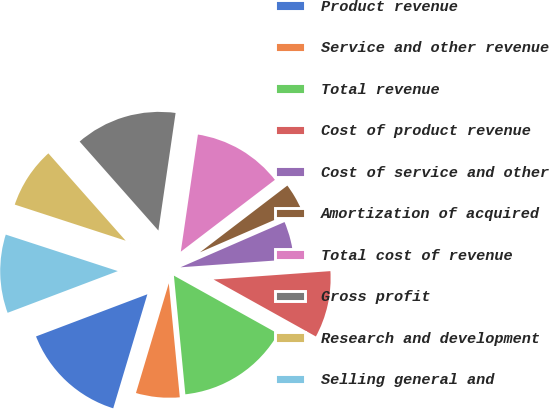Convert chart. <chart><loc_0><loc_0><loc_500><loc_500><pie_chart><fcel>Product revenue<fcel>Service and other revenue<fcel>Total revenue<fcel>Cost of product revenue<fcel>Cost of service and other<fcel>Amortization of acquired<fcel>Total cost of revenue<fcel>Gross profit<fcel>Research and development<fcel>Selling general and<nl><fcel>14.61%<fcel>6.16%<fcel>15.38%<fcel>9.23%<fcel>5.39%<fcel>3.85%<fcel>12.31%<fcel>13.84%<fcel>8.46%<fcel>10.77%<nl></chart> 